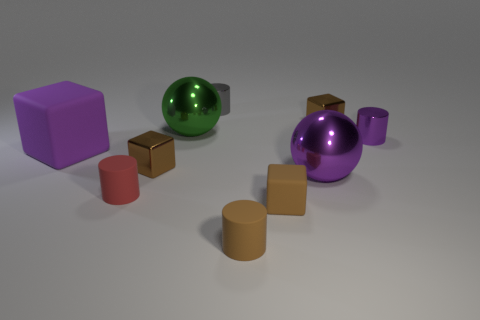There is a cylinder that is behind the small red object and in front of the gray metallic object; what color is it?
Your answer should be very brief. Purple. Are there any other things that have the same color as the large rubber block?
Provide a succinct answer. Yes. There is a tiny block that is behind the big metallic object behind the purple matte cube; what is its color?
Give a very brief answer. Brown. Does the green metallic object have the same size as the brown matte block?
Your answer should be very brief. No. Does the big sphere that is in front of the purple matte cube have the same material as the small brown cube in front of the small red matte object?
Ensure brevity in your answer.  No. There is a small brown shiny thing that is left of the brown metallic block that is to the right of the tiny brown matte thing behind the brown rubber cylinder; what is its shape?
Make the answer very short. Cube. Is the number of tiny gray metal objects greater than the number of metal cylinders?
Your response must be concise. No. Is there a small purple block?
Your response must be concise. No. How many objects are either small brown matte objects that are to the right of the big green thing or large green spheres behind the small purple metal thing?
Keep it short and to the point. 3. Are there fewer large purple spheres than small metal things?
Provide a short and direct response. Yes. 